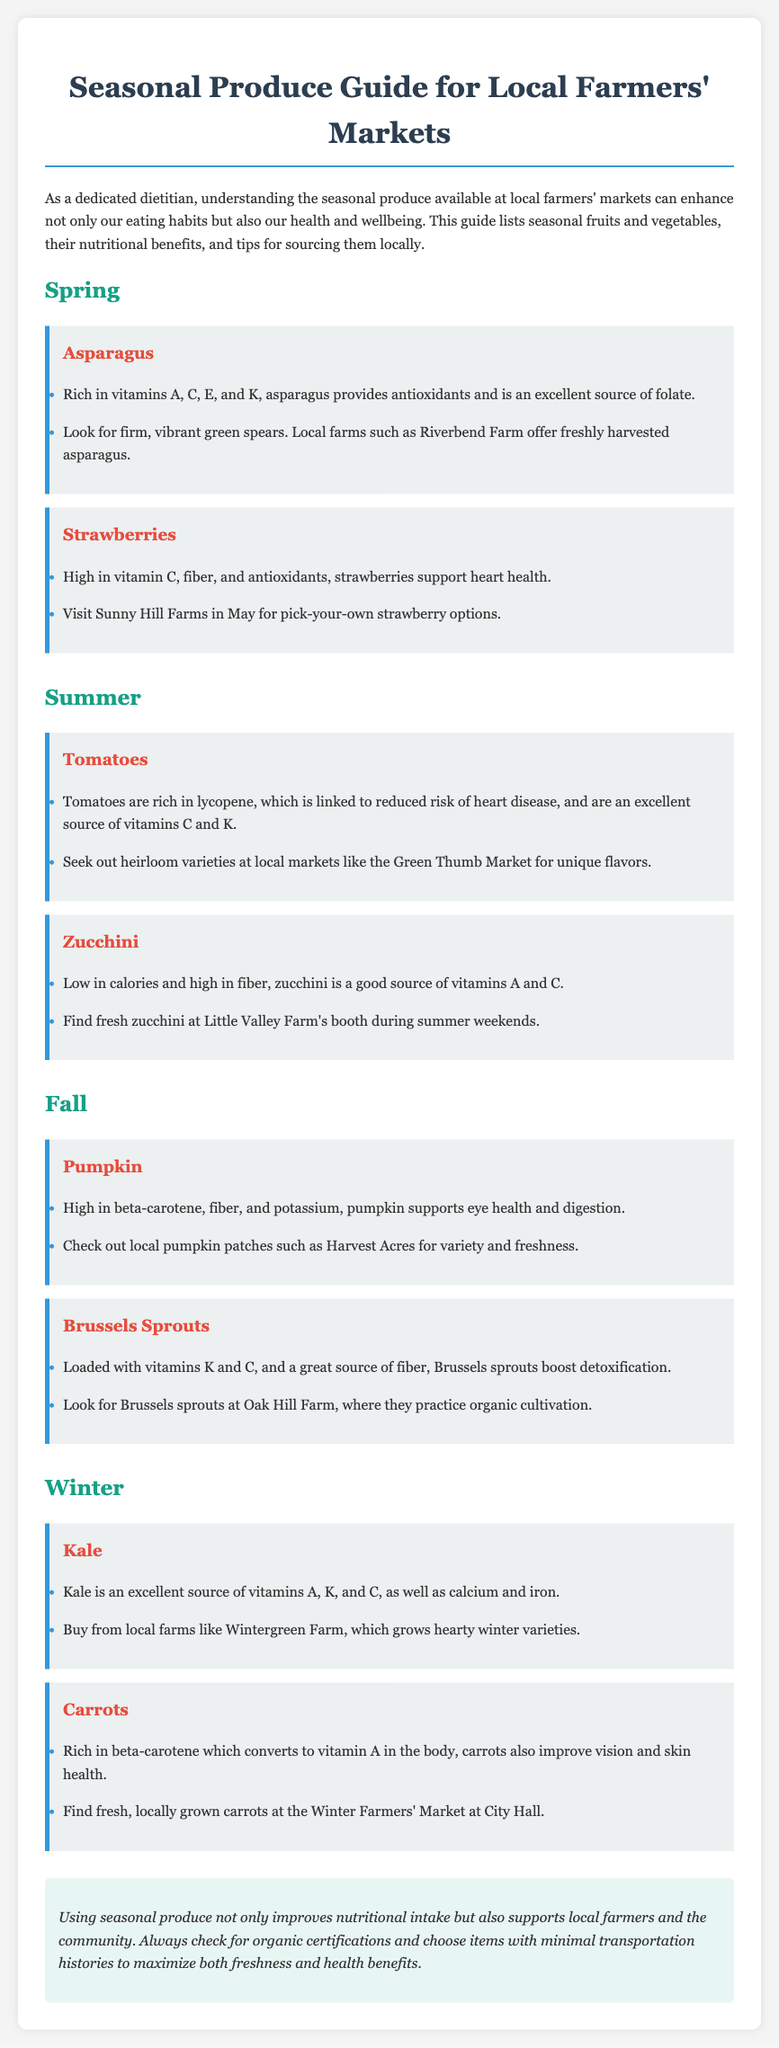What are the benefits of asparagus? Asparagus is rich in vitamins A, C, E, and K, provides antioxidants, and is an excellent source of folate.
Answer: Vitamins A, C, E, K, folate Where can you find strawberries for pick-your-own? You can find strawberries at Sunny Hill Farms in May.
Answer: Sunny Hill Farms Which vegetable is high in beta-carotene? The document mentions that pumpkin is high in beta-carotene.
Answer: Pumpkin How many types of produce are listed for fall? The document lists two types of produce for fall: pumpkin and Brussels sprouts.
Answer: Two What winter vegetable is noted for its calcium content? The vegetable noted for its calcium content in winter is kale.
Answer: Kale Which farmers' market has hybrid tomato varieties? The document indicates that Green Thumb Market has heirloom varieties.
Answer: Green Thumb Market What nutrient do carrots improve in the body? Carrots improve vision due to their beta-carotene content.
Answer: Vision What is the primary theme of the document? The primary theme of the document is about seasonal produce and its benefits.
Answer: Seasonal produce and benefits Where do you buy locally grown carrots? You can find locally grown carrots at the Winter Farmers' Market at City Hall.
Answer: Winter Farmers' Market at City Hall 